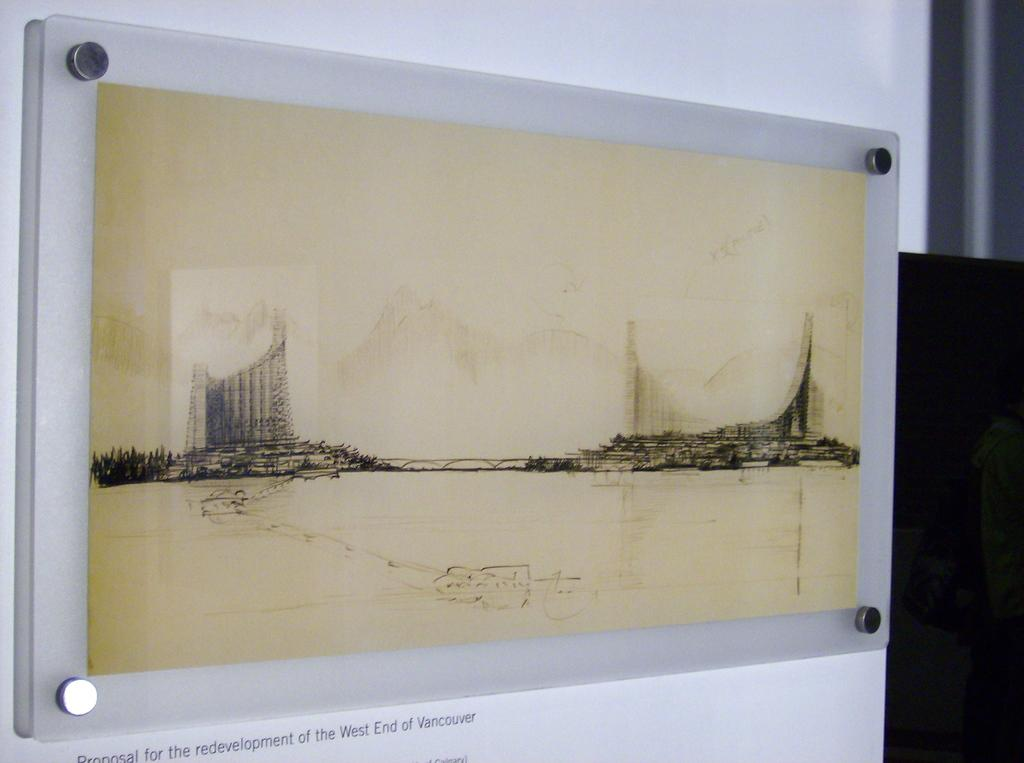What object is present in the image that typically holds a photo? There is a photo frame in the image. How is the photo frame positioned in the image? The photo frame is fixed to the wall. What can be seen in the photo within the frame? The photo contains images of buildings. What type of pets are visible in the photo frame? There are no pets visible in the photo frame; it contains images of buildings. What kind of apparatus is used to take the photo in the frame? The factual information provided does not mention any apparatus used to take the photo in the frame. 